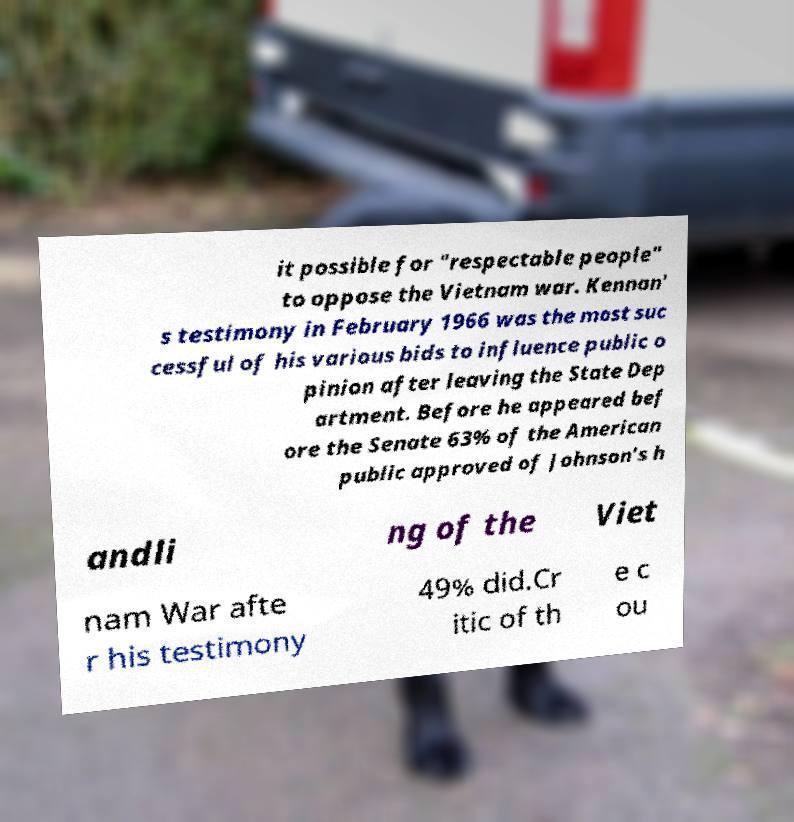Could you assist in decoding the text presented in this image and type it out clearly? it possible for "respectable people" to oppose the Vietnam war. Kennan' s testimony in February 1966 was the most suc cessful of his various bids to influence public o pinion after leaving the State Dep artment. Before he appeared bef ore the Senate 63% of the American public approved of Johnson's h andli ng of the Viet nam War afte r his testimony 49% did.Cr itic of th e c ou 